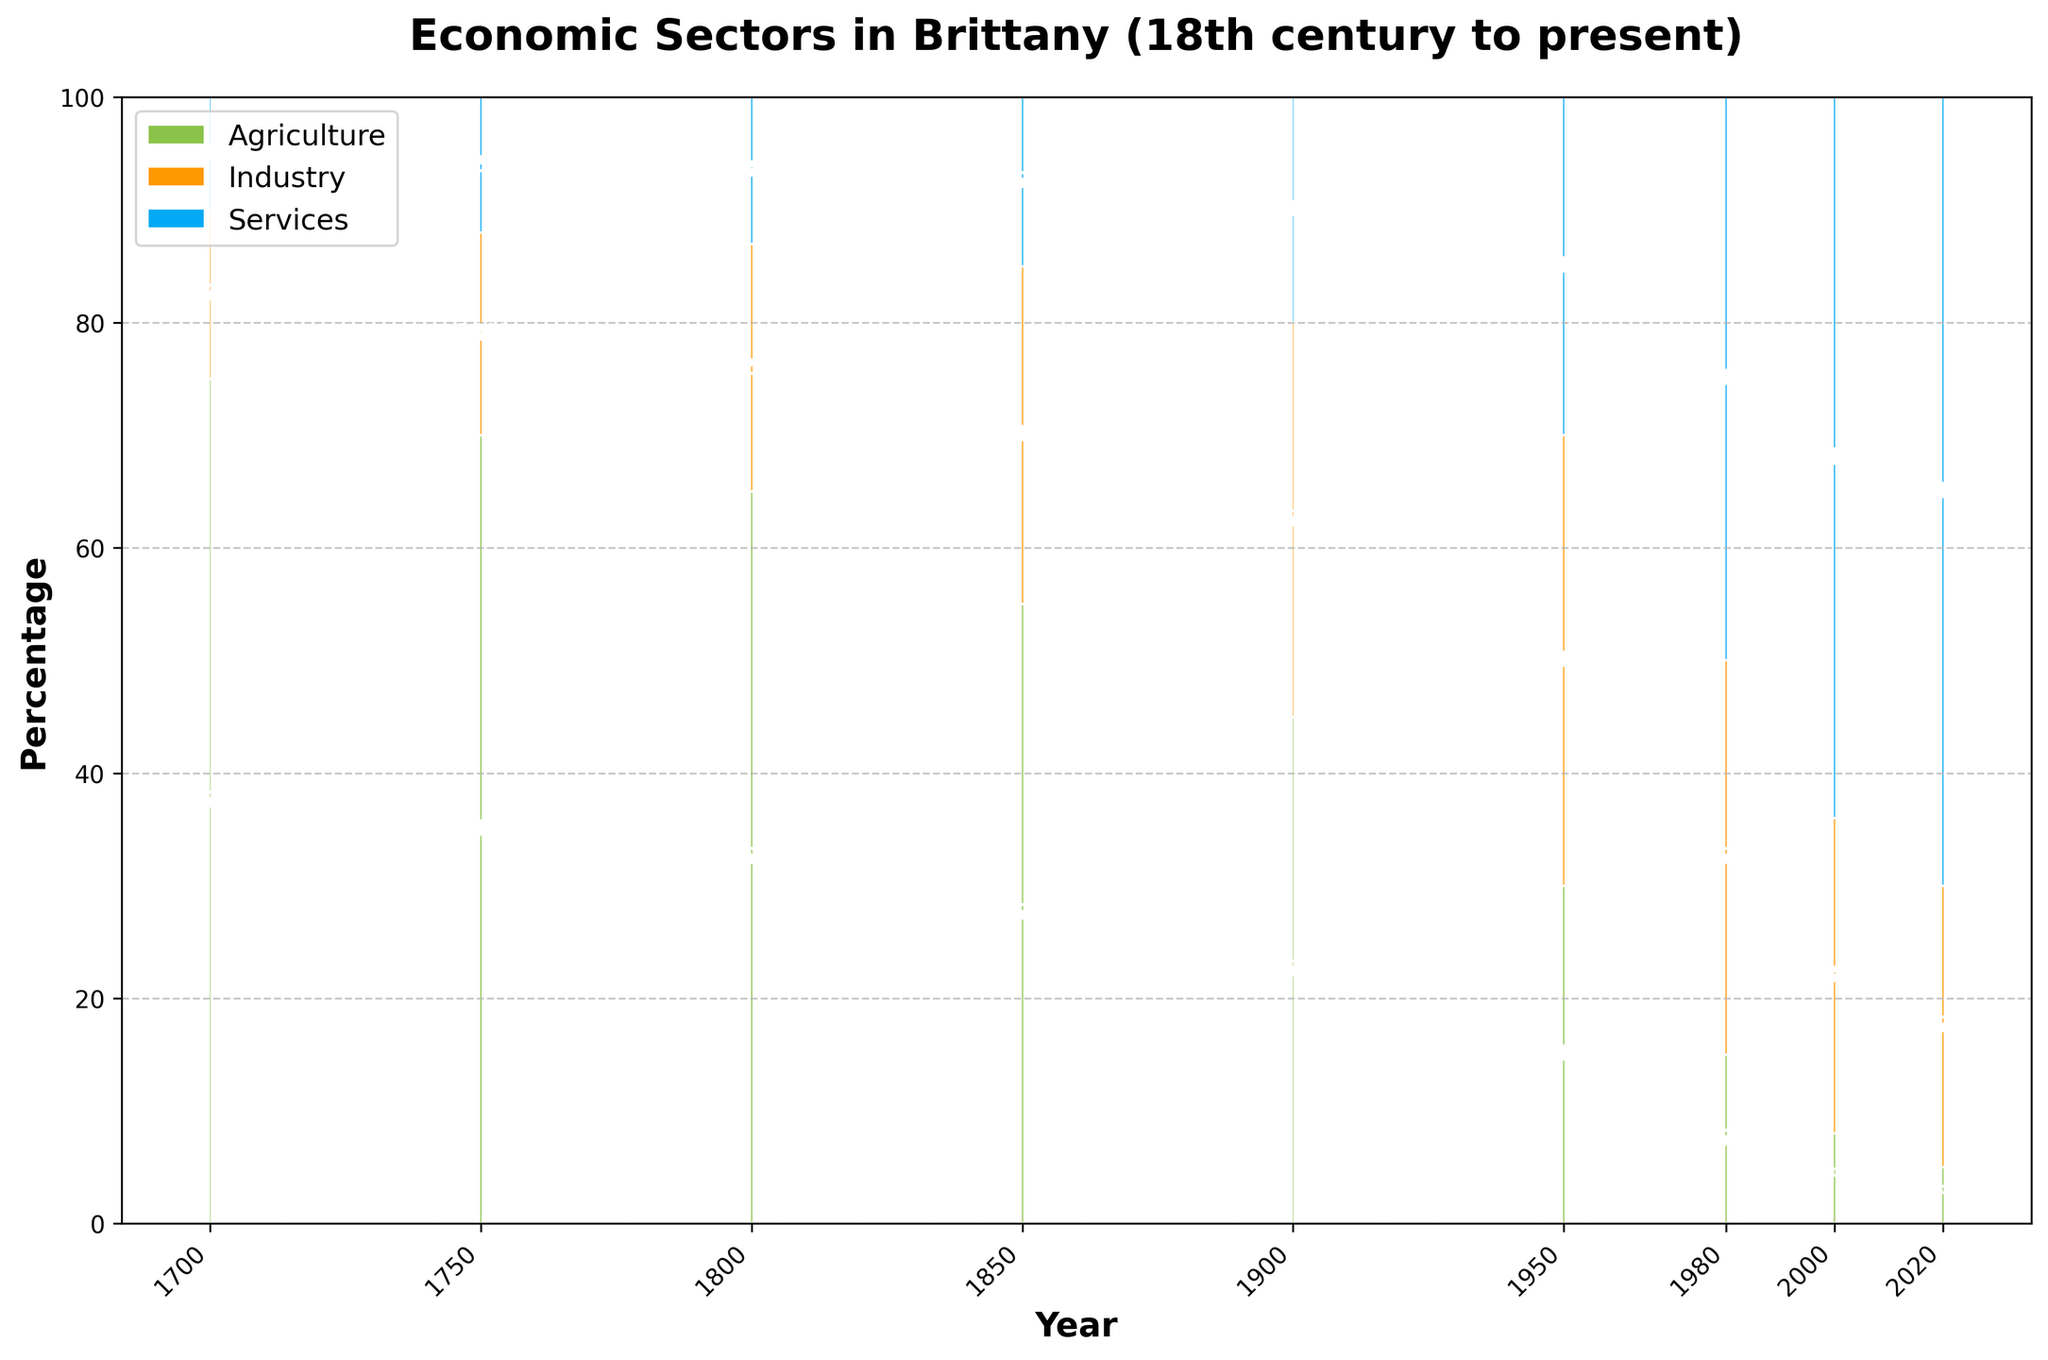Which year had the highest percentage of services? Look at the top segment of the bar for each year, the color representing services is blue, identify the highest bar segment.
Answer: 2020 In which year did agriculture's percentage drop below 10%? Check the green segments from each year until you find the first year below 10%.
Answer: 1980 How did the percentage of industry change from 1700 to 2020? Compare the orange bar segments in 1700 and 2020.
Answer: It increased from 15% to 25% What is the total percentage for non-agricultural sectors in 1850? Combine the percentages of industry and services (orange and blue segments) for 1850. Calculation: 30% (Industry) + 15% (Services) = 45%
Answer: 45% Compare the change in the percentage of services between 1950 and 2000. Find the differences in the blue segments between the two years: 64% (2000) - 30% (1950)
Answer: It increased by 34% Which year shows an equal percentage for agriculture and services, and what is that percentage? Look for the year where green and blue bar segments are equal in height.
Answer: 1950 (both 30%) When did the industry sector reach its peak percentage? Identify the year with the tallest orange segment among all bars.
Answer: 1950 By how much did the percentage of agriculture reduce between 1750 and 1800? Find the difference between the green segments of 1750 and 1800: 70% (1750) - 65% (1800)
Answer: It reduced by 5% Which sector overtook agriculture in percentage first and in which year? Identify the first occurrence when the orange (Industry) or blue (Services) segment is taller than the green (Agriculture) segment.
Answer: Industry in 1950 What percentage of the total economy was accounted for by agriculture and industry combined in 2000? Sum up the green and orange segments for 2000: 8% (Agriculture) + 28% (Industry) = 36%
Answer: 36% 